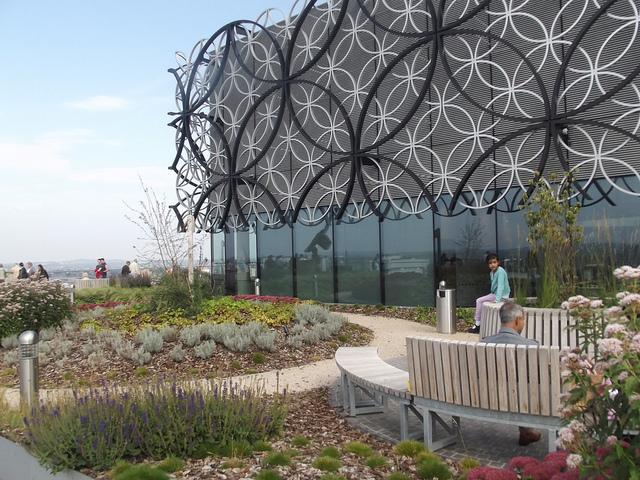What should be put in the hole near the nearby child?

Choices:
A) lightbulb
B) key
C) hand
D) trash trash 